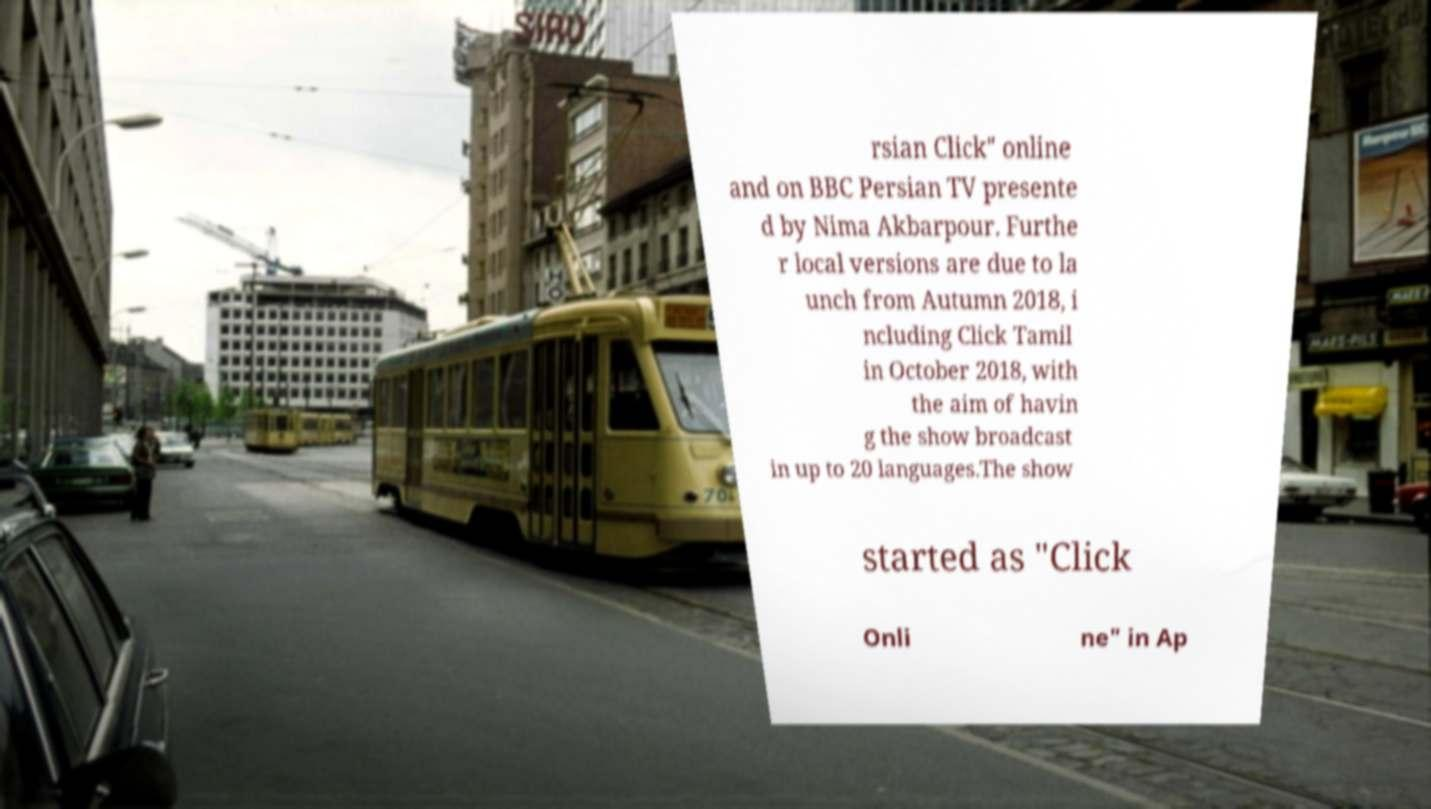There's text embedded in this image that I need extracted. Can you transcribe it verbatim? rsian Click" online and on BBC Persian TV presente d by Nima Akbarpour. Furthe r local versions are due to la unch from Autumn 2018, i ncluding Click Tamil in October 2018, with the aim of havin g the show broadcast in up to 20 languages.The show started as "Click Onli ne" in Ap 